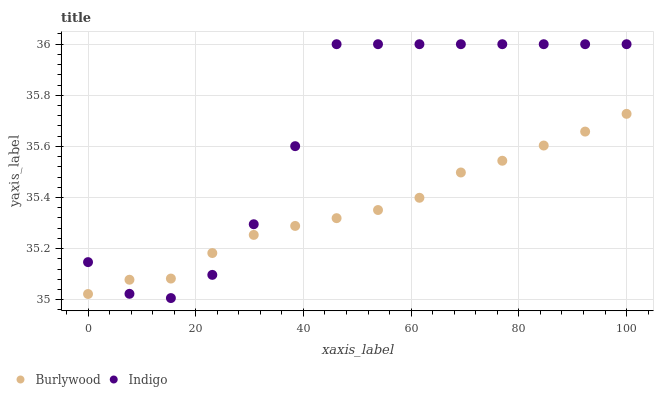Does Burlywood have the minimum area under the curve?
Answer yes or no. Yes. Does Indigo have the maximum area under the curve?
Answer yes or no. Yes. Does Indigo have the minimum area under the curve?
Answer yes or no. No. Is Burlywood the smoothest?
Answer yes or no. Yes. Is Indigo the roughest?
Answer yes or no. Yes. Is Indigo the smoothest?
Answer yes or no. No. Does Indigo have the lowest value?
Answer yes or no. Yes. Does Indigo have the highest value?
Answer yes or no. Yes. Does Indigo intersect Burlywood?
Answer yes or no. Yes. Is Indigo less than Burlywood?
Answer yes or no. No. Is Indigo greater than Burlywood?
Answer yes or no. No. 